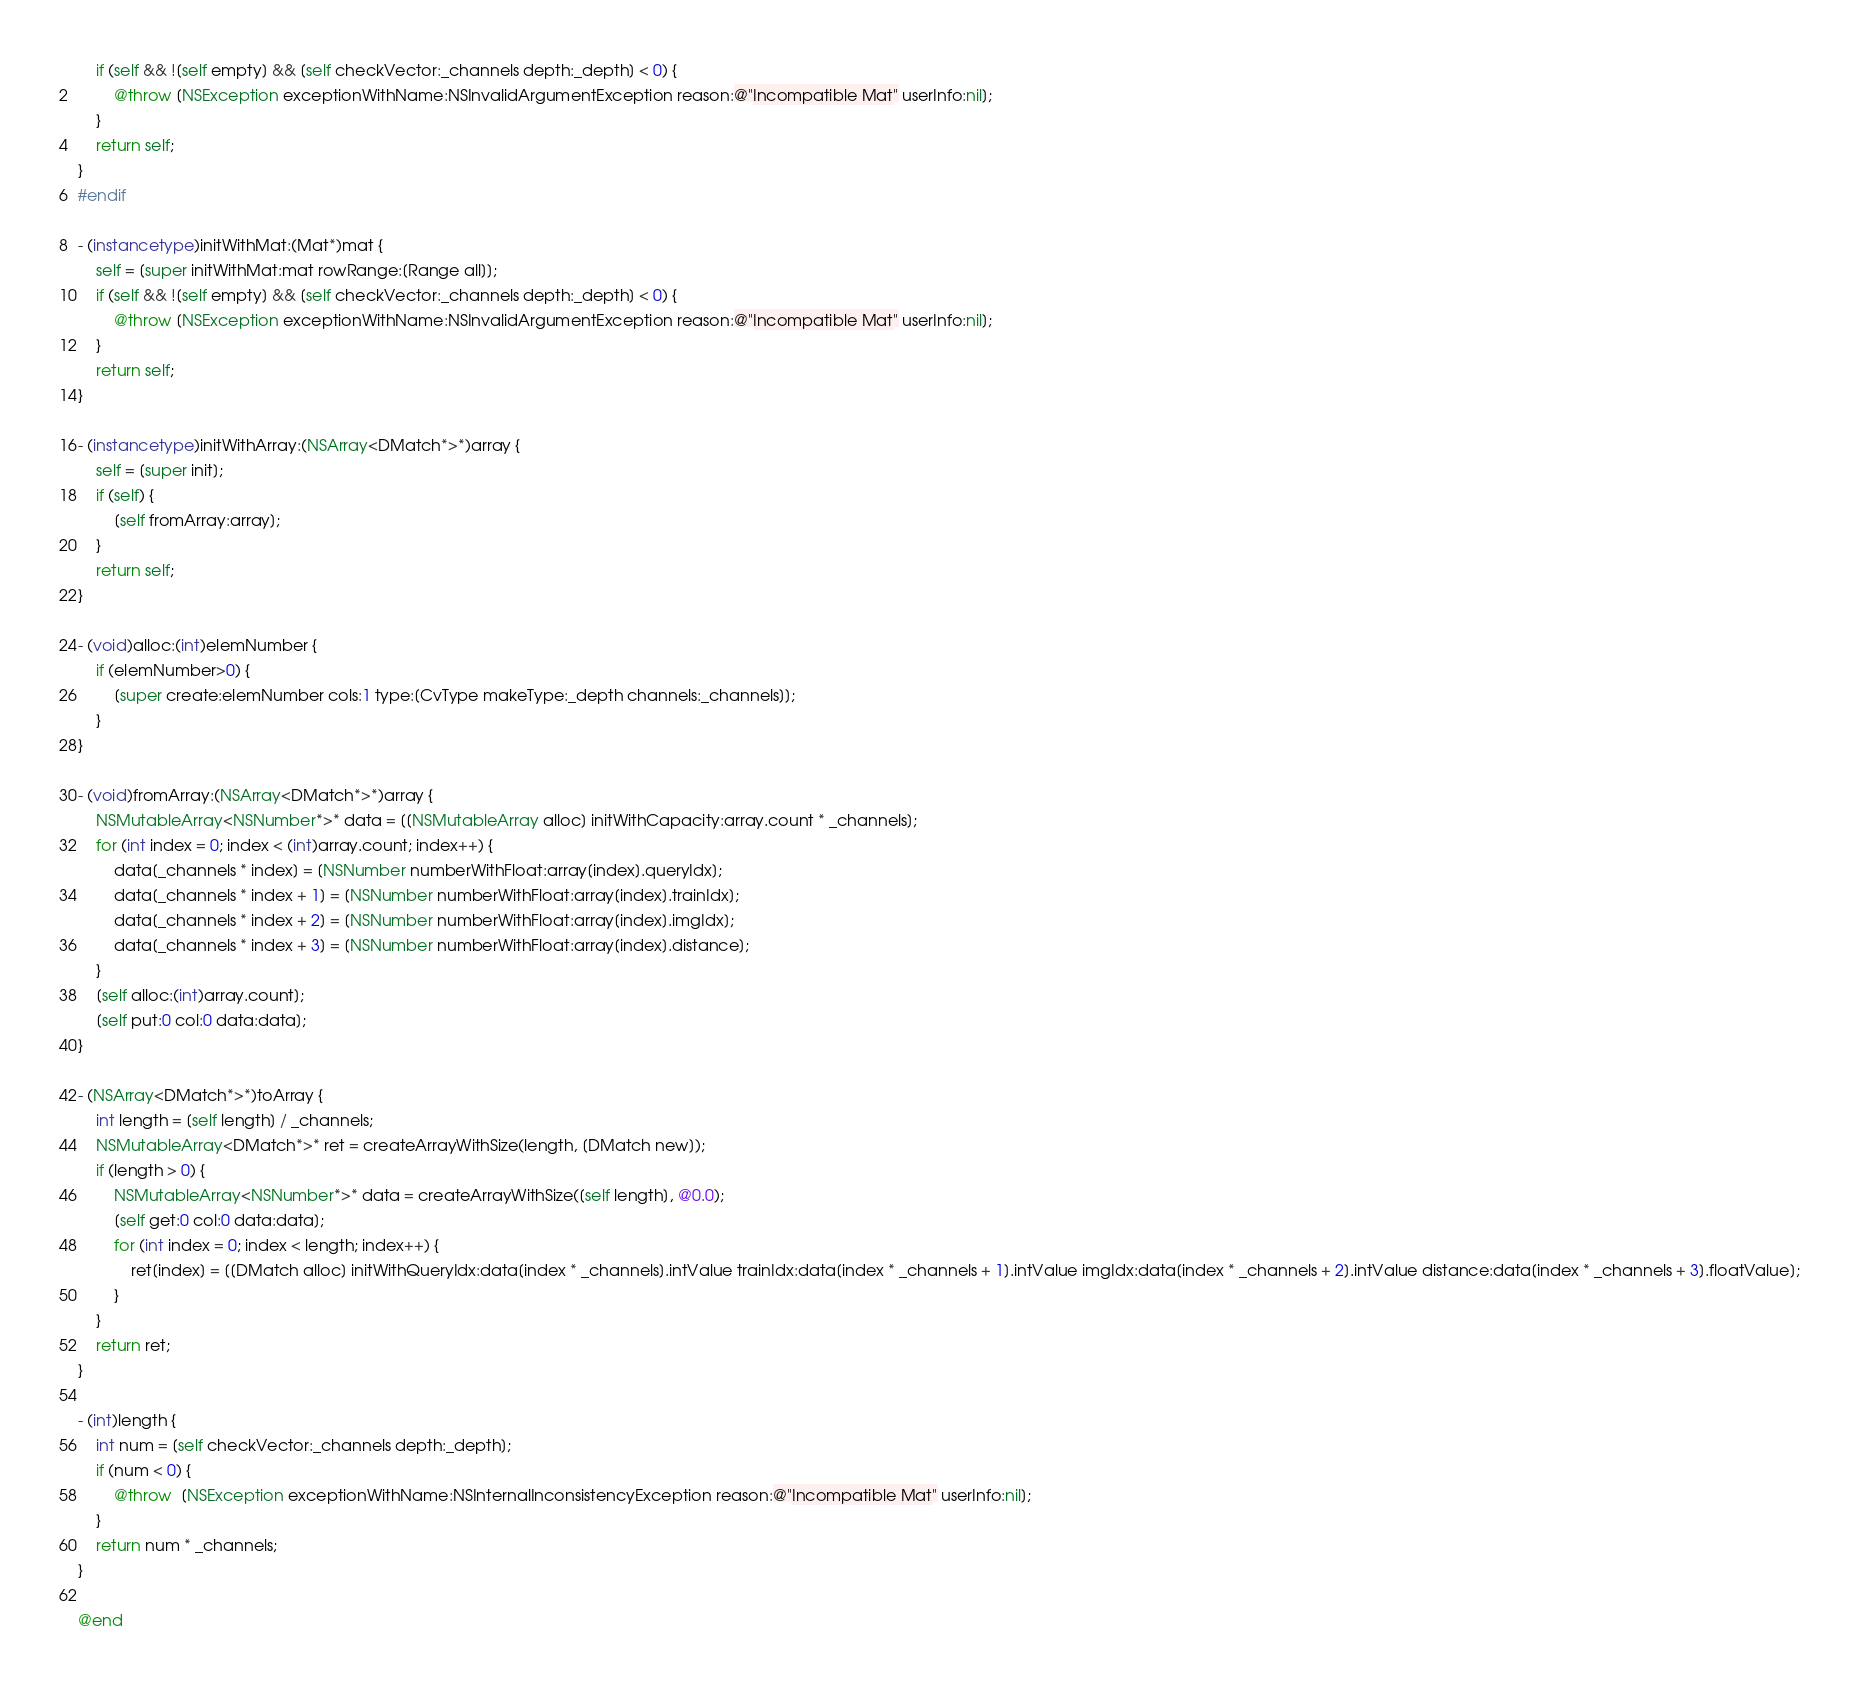<code> <loc_0><loc_0><loc_500><loc_500><_ObjectiveC_>    if (self && ![self empty] && [self checkVector:_channels depth:_depth] < 0) {
        @throw [NSException exceptionWithName:NSInvalidArgumentException reason:@"Incompatible Mat" userInfo:nil];
    }
    return self;
}
#endif

- (instancetype)initWithMat:(Mat*)mat {
    self = [super initWithMat:mat rowRange:[Range all]];
    if (self && ![self empty] && [self checkVector:_channels depth:_depth] < 0) {
        @throw [NSException exceptionWithName:NSInvalidArgumentException reason:@"Incompatible Mat" userInfo:nil];
    }
    return self;
}

- (instancetype)initWithArray:(NSArray<DMatch*>*)array {
    self = [super init];
    if (self) {
        [self fromArray:array];
    }
    return self;
}

- (void)alloc:(int)elemNumber {
    if (elemNumber>0) {
        [super create:elemNumber cols:1 type:[CvType makeType:_depth channels:_channels]];
    }
}

- (void)fromArray:(NSArray<DMatch*>*)array {
    NSMutableArray<NSNumber*>* data = [[NSMutableArray alloc] initWithCapacity:array.count * _channels];
    for (int index = 0; index < (int)array.count; index++) {
        data[_channels * index] = [NSNumber numberWithFloat:array[index].queryIdx];
        data[_channels * index + 1] = [NSNumber numberWithFloat:array[index].trainIdx];
        data[_channels * index + 2] = [NSNumber numberWithFloat:array[index].imgIdx];
        data[_channels * index + 3] = [NSNumber numberWithFloat:array[index].distance];
    }
    [self alloc:(int)array.count];
    [self put:0 col:0 data:data];
}

- (NSArray<DMatch*>*)toArray {
    int length = [self length] / _channels;
    NSMutableArray<DMatch*>* ret = createArrayWithSize(length, [DMatch new]);
    if (length > 0) {
        NSMutableArray<NSNumber*>* data = createArrayWithSize([self length], @0.0);
        [self get:0 col:0 data:data];
        for (int index = 0; index < length; index++) {
            ret[index] = [[DMatch alloc] initWithQueryIdx:data[index * _channels].intValue trainIdx:data[index * _channels + 1].intValue imgIdx:data[index * _channels + 2].intValue distance:data[index * _channels + 3].floatValue];
        }
    }
    return ret;
}

- (int)length {
    int num = [self checkVector:_channels depth:_depth];
    if (num < 0) {
        @throw  [NSException exceptionWithName:NSInternalInconsistencyException reason:@"Incompatible Mat" userInfo:nil];
    }
    return num * _channels;
}

@end
</code> 